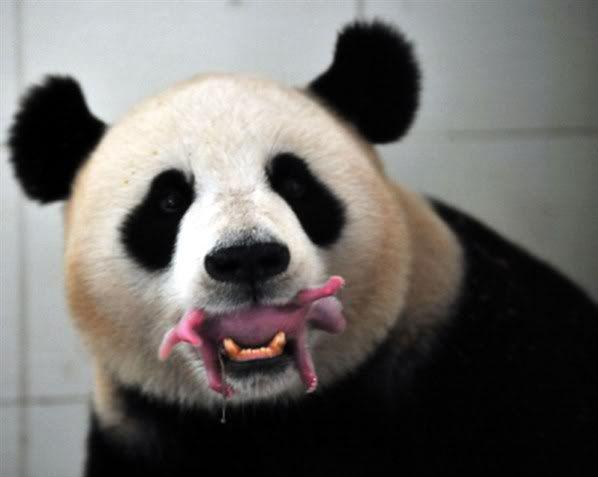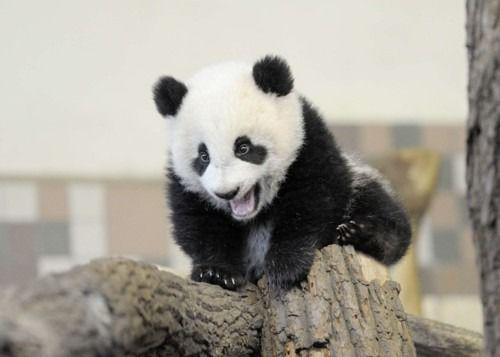The first image is the image on the left, the second image is the image on the right. Considering the images on both sides, is "The right image shows a baby panda with a pink nose and fuzzy fur, posed on a blanket with the toes of two limbs turning inward." valid? Answer yes or no. No. 